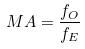Convert formula to latex. <formula><loc_0><loc_0><loc_500><loc_500>M A = \frac { f _ { O } } { f _ { E } }</formula> 